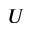Convert formula to latex. <formula><loc_0><loc_0><loc_500><loc_500>U</formula> 